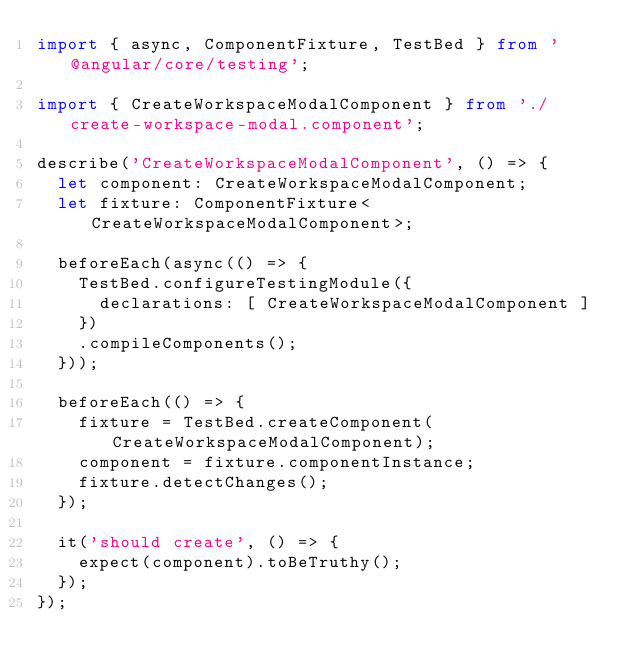<code> <loc_0><loc_0><loc_500><loc_500><_TypeScript_>import { async, ComponentFixture, TestBed } from '@angular/core/testing';

import { CreateWorkspaceModalComponent } from './create-workspace-modal.component';

describe('CreateWorkspaceModalComponent', () => {
  let component: CreateWorkspaceModalComponent;
  let fixture: ComponentFixture<CreateWorkspaceModalComponent>;

  beforeEach(async(() => {
    TestBed.configureTestingModule({
      declarations: [ CreateWorkspaceModalComponent ]
    })
    .compileComponents();
  }));

  beforeEach(() => {
    fixture = TestBed.createComponent(CreateWorkspaceModalComponent);
    component = fixture.componentInstance;
    fixture.detectChanges();
  });

  it('should create', () => {
    expect(component).toBeTruthy();
  });
});
</code> 